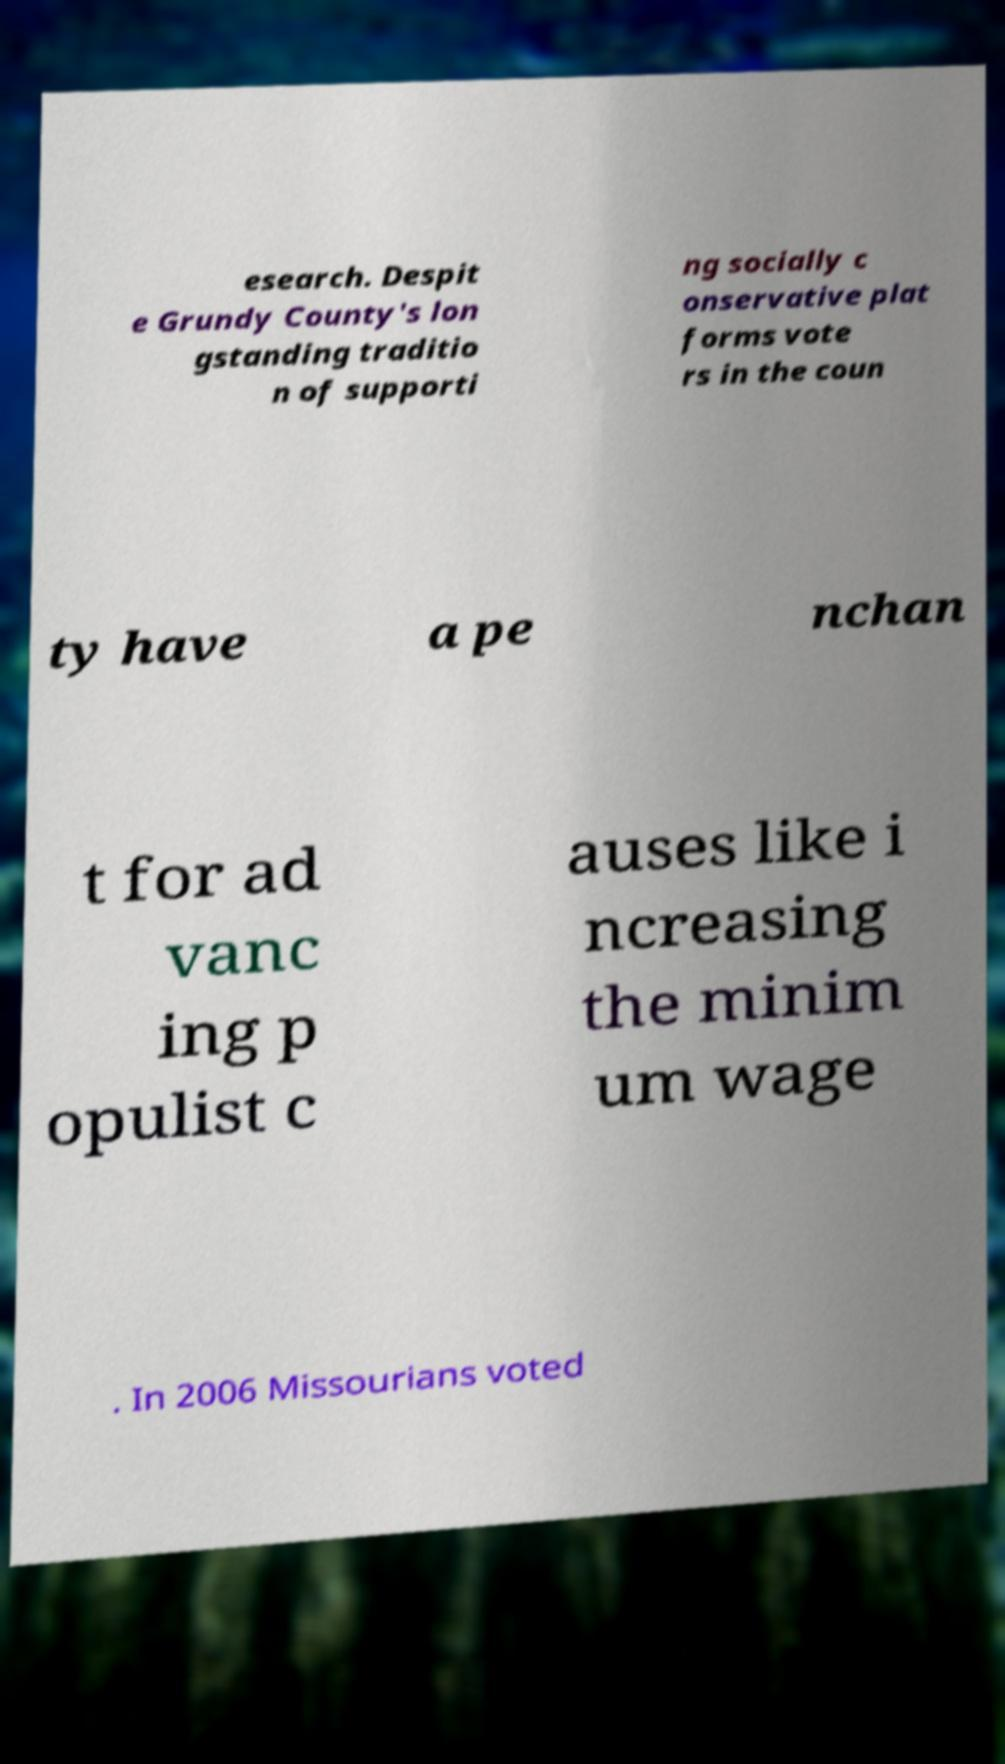Could you extract and type out the text from this image? esearch. Despit e Grundy County's lon gstanding traditio n of supporti ng socially c onservative plat forms vote rs in the coun ty have a pe nchan t for ad vanc ing p opulist c auses like i ncreasing the minim um wage . In 2006 Missourians voted 